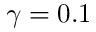<formula> <loc_0><loc_0><loc_500><loc_500>\gamma = 0 . 1</formula> 